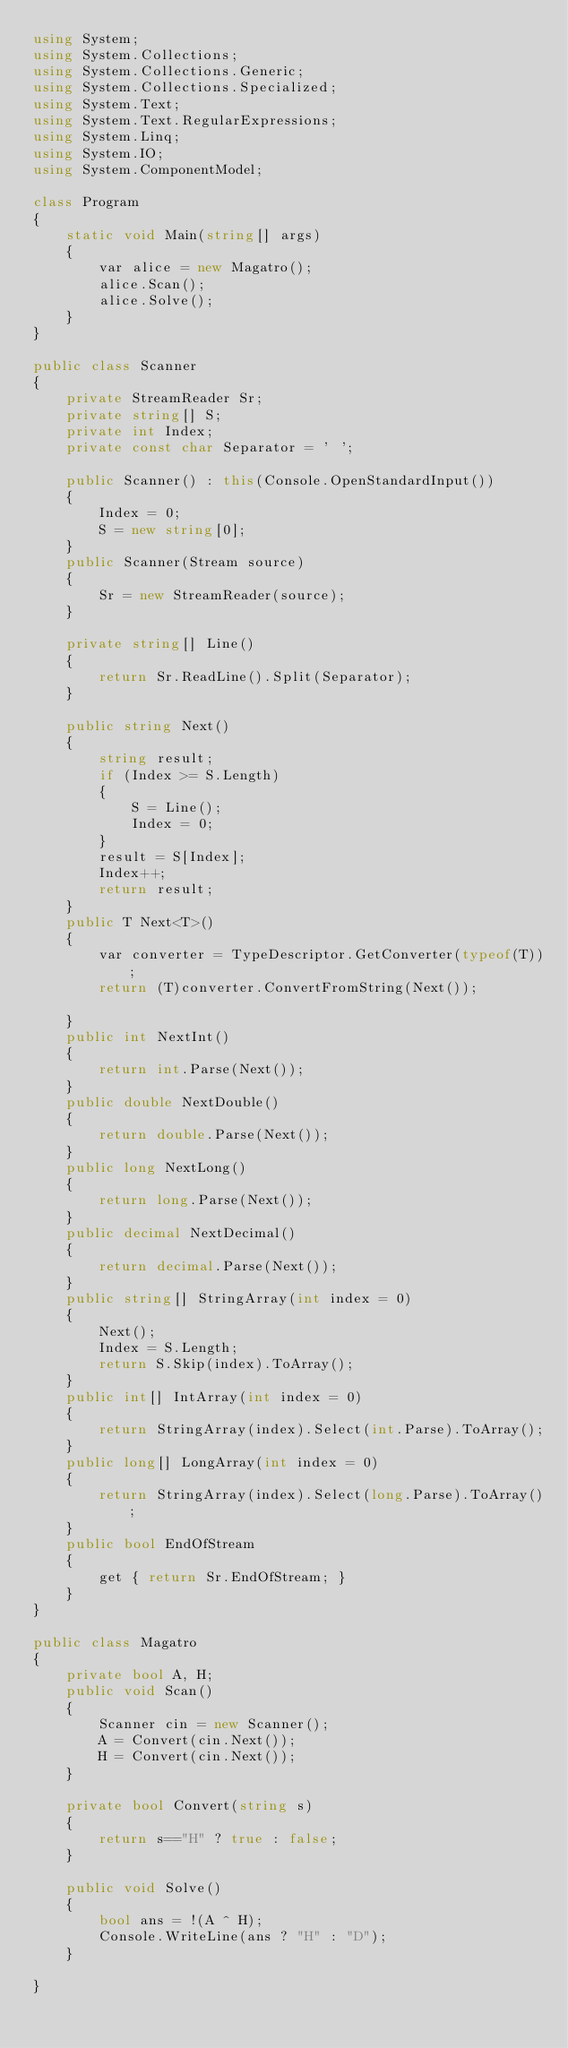Convert code to text. <code><loc_0><loc_0><loc_500><loc_500><_C#_>using System;
using System.Collections;
using System.Collections.Generic;
using System.Collections.Specialized;
using System.Text;
using System.Text.RegularExpressions;
using System.Linq;
using System.IO;
using System.ComponentModel;

class Program
{
    static void Main(string[] args)
    {
        var alice = new Magatro();
        alice.Scan();
        alice.Solve();
    }
}

public class Scanner
{
    private StreamReader Sr;
    private string[] S;
    private int Index;
    private const char Separator = ' ';

    public Scanner() : this(Console.OpenStandardInput())
    {
        Index = 0;
        S = new string[0];
    }
    public Scanner(Stream source)
    {
        Sr = new StreamReader(source);
    }

    private string[] Line()
    {
        return Sr.ReadLine().Split(Separator);
    }

    public string Next()
    {
        string result;
        if (Index >= S.Length)
        {
            S = Line();
            Index = 0;
        }
        result = S[Index];
        Index++;
        return result;
    }
    public T Next<T>()
    {
        var converter = TypeDescriptor.GetConverter(typeof(T));
        return (T)converter.ConvertFromString(Next());

    }
    public int NextInt()
    {
        return int.Parse(Next());
    }
    public double NextDouble()
    {
        return double.Parse(Next());
    }
    public long NextLong()
    {
        return long.Parse(Next());
    }
    public decimal NextDecimal()
    {
        return decimal.Parse(Next());
    }
    public string[] StringArray(int index = 0)
    {
        Next();
        Index = S.Length;
        return S.Skip(index).ToArray();
    }
    public int[] IntArray(int index = 0)
    {
        return StringArray(index).Select(int.Parse).ToArray();
    }
    public long[] LongArray(int index = 0)
    {
        return StringArray(index).Select(long.Parse).ToArray();
    }
    public bool EndOfStream
    {
        get { return Sr.EndOfStream; }
    }
}

public class Magatro
{
    private bool A, H;
    public void Scan()
    {
        Scanner cin = new Scanner();
        A = Convert(cin.Next());
        H = Convert(cin.Next());
    }

    private bool Convert(string s)
    {
        return s=="H" ? true : false;
    }

    public void Solve()
    {
        bool ans = !(A ^ H);
        Console.WriteLine(ans ? "H" : "D");
    }

}

</code> 